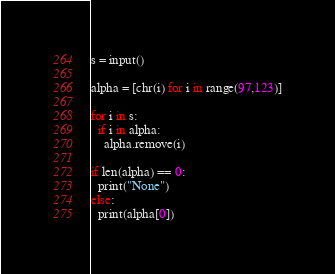Convert code to text. <code><loc_0><loc_0><loc_500><loc_500><_Python_>s = input()

alpha = [chr(i) for i in range(97,123)]

for i in s:
  if i in alpha:
    alpha.remove(i)

if len(alpha) == 0:
  print("None")
else:
  print(alpha[0])</code> 